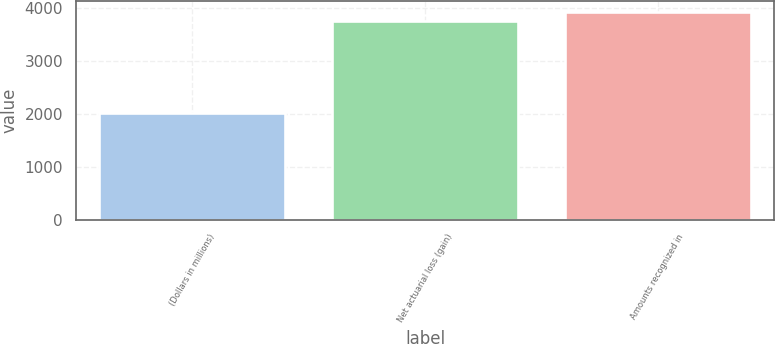Convert chart to OTSL. <chart><loc_0><loc_0><loc_500><loc_500><bar_chart><fcel>(Dollars in millions)<fcel>Net actuarial loss (gain)<fcel>Amounts recognized in<nl><fcel>2013<fcel>3749<fcel>3924.1<nl></chart> 